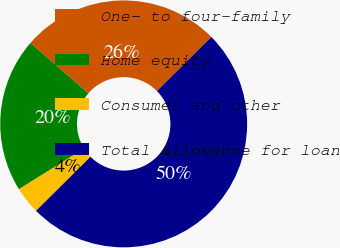Convert chart. <chart><loc_0><loc_0><loc_500><loc_500><pie_chart><fcel>One- to four-family<fcel>Home equity<fcel>Consumer and other<fcel>Total allowance for loan<nl><fcel>26.2%<fcel>20.25%<fcel>3.55%<fcel>50.0%<nl></chart> 